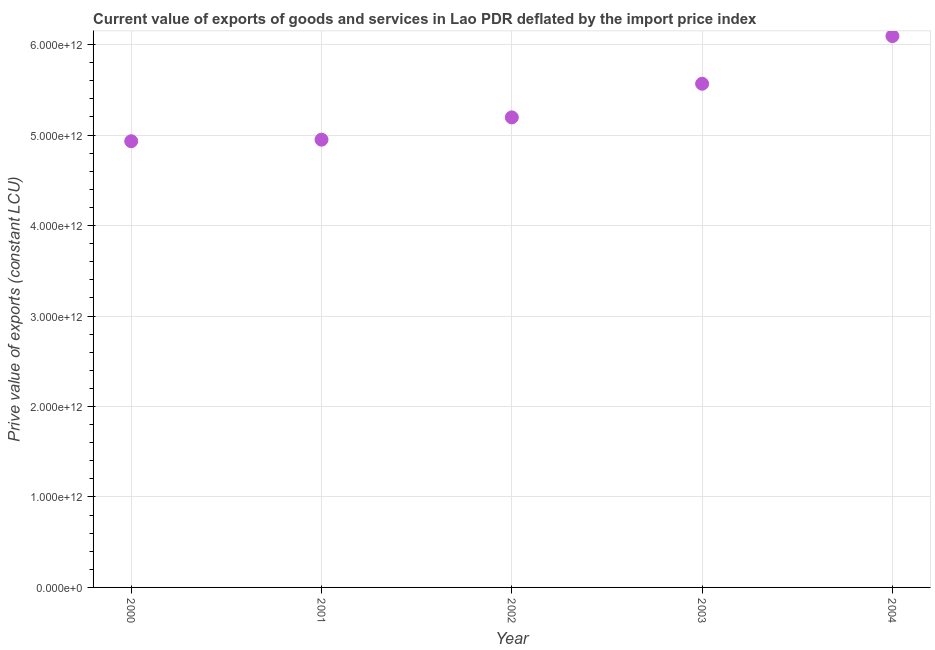What is the price value of exports in 2001?
Make the answer very short. 4.95e+12. Across all years, what is the maximum price value of exports?
Keep it short and to the point. 6.09e+12. Across all years, what is the minimum price value of exports?
Your answer should be compact. 4.93e+12. What is the sum of the price value of exports?
Provide a succinct answer. 2.67e+13. What is the difference between the price value of exports in 2002 and 2004?
Give a very brief answer. -8.99e+11. What is the average price value of exports per year?
Give a very brief answer. 5.35e+12. What is the median price value of exports?
Give a very brief answer. 5.20e+12. In how many years, is the price value of exports greater than 200000000000 LCU?
Make the answer very short. 5. What is the ratio of the price value of exports in 2001 to that in 2004?
Your answer should be compact. 0.81. Is the difference between the price value of exports in 2001 and 2002 greater than the difference between any two years?
Your response must be concise. No. What is the difference between the highest and the second highest price value of exports?
Your answer should be compact. 5.27e+11. Is the sum of the price value of exports in 2000 and 2004 greater than the maximum price value of exports across all years?
Give a very brief answer. Yes. What is the difference between the highest and the lowest price value of exports?
Provide a short and direct response. 1.16e+12. How many years are there in the graph?
Ensure brevity in your answer.  5. What is the difference between two consecutive major ticks on the Y-axis?
Make the answer very short. 1.00e+12. Does the graph contain any zero values?
Make the answer very short. No. Does the graph contain grids?
Ensure brevity in your answer.  Yes. What is the title of the graph?
Provide a succinct answer. Current value of exports of goods and services in Lao PDR deflated by the import price index. What is the label or title of the Y-axis?
Give a very brief answer. Prive value of exports (constant LCU). What is the Prive value of exports (constant LCU) in 2000?
Keep it short and to the point. 4.93e+12. What is the Prive value of exports (constant LCU) in 2001?
Ensure brevity in your answer.  4.95e+12. What is the Prive value of exports (constant LCU) in 2002?
Offer a terse response. 5.20e+12. What is the Prive value of exports (constant LCU) in 2003?
Your answer should be very brief. 5.57e+12. What is the Prive value of exports (constant LCU) in 2004?
Your answer should be very brief. 6.09e+12. What is the difference between the Prive value of exports (constant LCU) in 2000 and 2001?
Provide a succinct answer. -1.71e+1. What is the difference between the Prive value of exports (constant LCU) in 2000 and 2002?
Your answer should be compact. -2.63e+11. What is the difference between the Prive value of exports (constant LCU) in 2000 and 2003?
Offer a very short reply. -6.35e+11. What is the difference between the Prive value of exports (constant LCU) in 2000 and 2004?
Your answer should be very brief. -1.16e+12. What is the difference between the Prive value of exports (constant LCU) in 2001 and 2002?
Provide a short and direct response. -2.46e+11. What is the difference between the Prive value of exports (constant LCU) in 2001 and 2003?
Your answer should be very brief. -6.18e+11. What is the difference between the Prive value of exports (constant LCU) in 2001 and 2004?
Keep it short and to the point. -1.14e+12. What is the difference between the Prive value of exports (constant LCU) in 2002 and 2003?
Provide a succinct answer. -3.72e+11. What is the difference between the Prive value of exports (constant LCU) in 2002 and 2004?
Make the answer very short. -8.99e+11. What is the difference between the Prive value of exports (constant LCU) in 2003 and 2004?
Ensure brevity in your answer.  -5.27e+11. What is the ratio of the Prive value of exports (constant LCU) in 2000 to that in 2001?
Provide a short and direct response. 1. What is the ratio of the Prive value of exports (constant LCU) in 2000 to that in 2002?
Your answer should be very brief. 0.95. What is the ratio of the Prive value of exports (constant LCU) in 2000 to that in 2003?
Your answer should be compact. 0.89. What is the ratio of the Prive value of exports (constant LCU) in 2000 to that in 2004?
Provide a succinct answer. 0.81. What is the ratio of the Prive value of exports (constant LCU) in 2001 to that in 2002?
Your answer should be very brief. 0.95. What is the ratio of the Prive value of exports (constant LCU) in 2001 to that in 2003?
Ensure brevity in your answer.  0.89. What is the ratio of the Prive value of exports (constant LCU) in 2001 to that in 2004?
Give a very brief answer. 0.81. What is the ratio of the Prive value of exports (constant LCU) in 2002 to that in 2003?
Provide a succinct answer. 0.93. What is the ratio of the Prive value of exports (constant LCU) in 2002 to that in 2004?
Your answer should be compact. 0.85. What is the ratio of the Prive value of exports (constant LCU) in 2003 to that in 2004?
Provide a short and direct response. 0.91. 